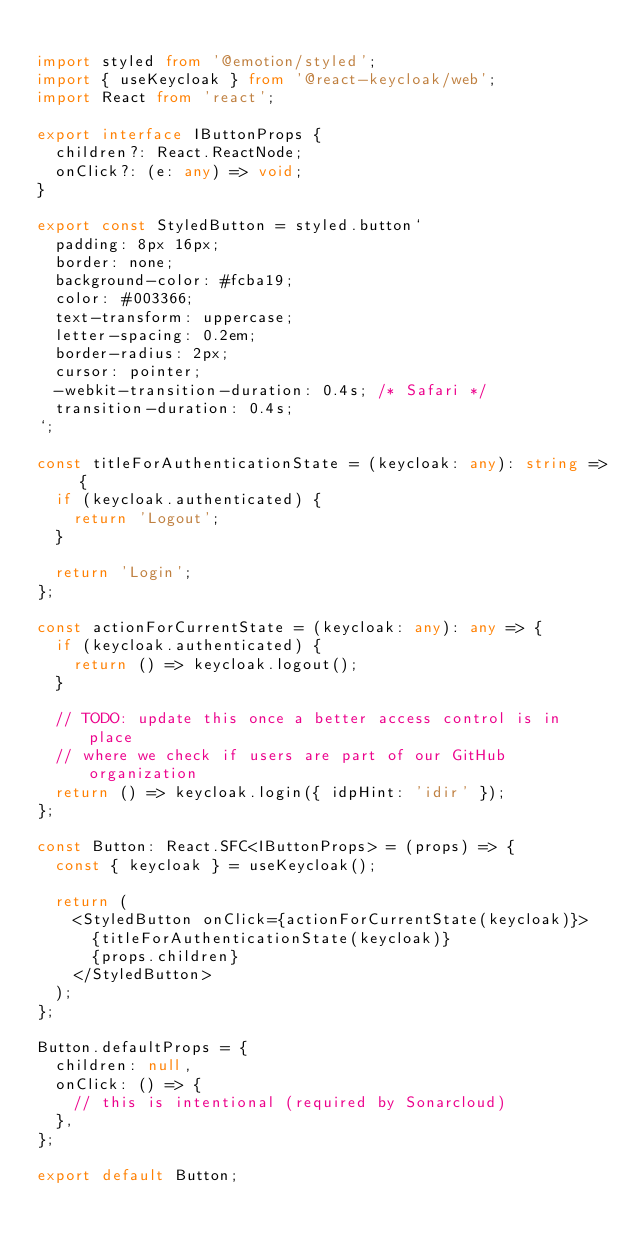<code> <loc_0><loc_0><loc_500><loc_500><_TypeScript_>
import styled from '@emotion/styled';
import { useKeycloak } from '@react-keycloak/web';
import React from 'react';

export interface IButtonProps {
  children?: React.ReactNode;
  onClick?: (e: any) => void;
}

export const StyledButton = styled.button`
  padding: 8px 16px;
  border: none;
  background-color: #fcba19;
  color: #003366;
  text-transform: uppercase;
  letter-spacing: 0.2em;
  border-radius: 2px;
  cursor: pointer;
  -webkit-transition-duration: 0.4s; /* Safari */
  transition-duration: 0.4s;
`;

const titleForAuthenticationState = (keycloak: any): string => {
  if (keycloak.authenticated) {
    return 'Logout';
  }

  return 'Login';
};

const actionForCurrentState = (keycloak: any): any => {
  if (keycloak.authenticated) {
    return () => keycloak.logout();
  }

  // TODO: update this once a better access control is in place
  // where we check if users are part of our GitHub organization
  return () => keycloak.login({ idpHint: 'idir' });
};

const Button: React.SFC<IButtonProps> = (props) => {
  const { keycloak } = useKeycloak();

  return (
    <StyledButton onClick={actionForCurrentState(keycloak)}>
      {titleForAuthenticationState(keycloak)}
      {props.children}
    </StyledButton>
  );
};

Button.defaultProps = {
  children: null,
  onClick: () => {
    // this is intentional (required by Sonarcloud)
  },
};

export default Button;
</code> 